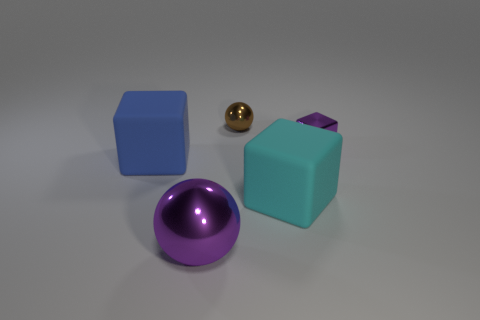Can you describe the lighting of the scene? The lighting of the scene is soft and diffuse, indicating an environment lit possibly by a large overhead light or through global illumination methods often used in rendering software. There are soft shadows under each object, suggesting the light source is not directly overhead but at an angle, casting a gentle shadow to one side of the objects. 